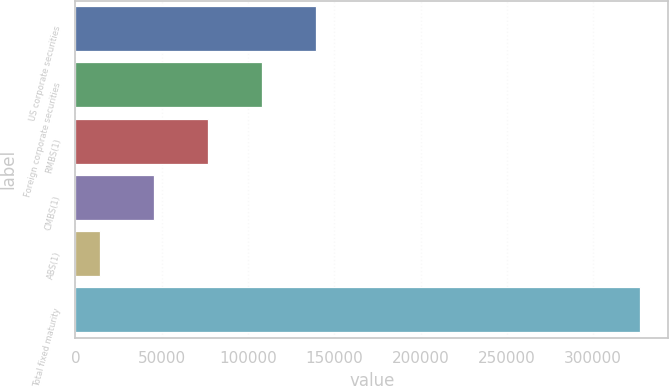<chart> <loc_0><loc_0><loc_500><loc_500><bar_chart><fcel>US corporate securities<fcel>Foreign corporate securities<fcel>RMBS(1)<fcel>CMBS(1)<fcel>ABS(1)<fcel>Total fixed maturity<nl><fcel>139488<fcel>108188<fcel>76888.8<fcel>45589.4<fcel>14290<fcel>327284<nl></chart> 